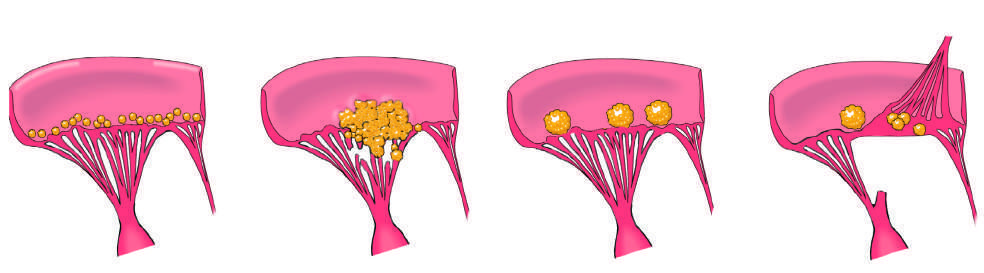re acute rheumatic mitral valvulitis characterized by large, irregular, often destructive masses that can extend from valve leaflets onto adjacent structures e.g., chordae or myocardium?
Answer the question using a single word or phrase. No 